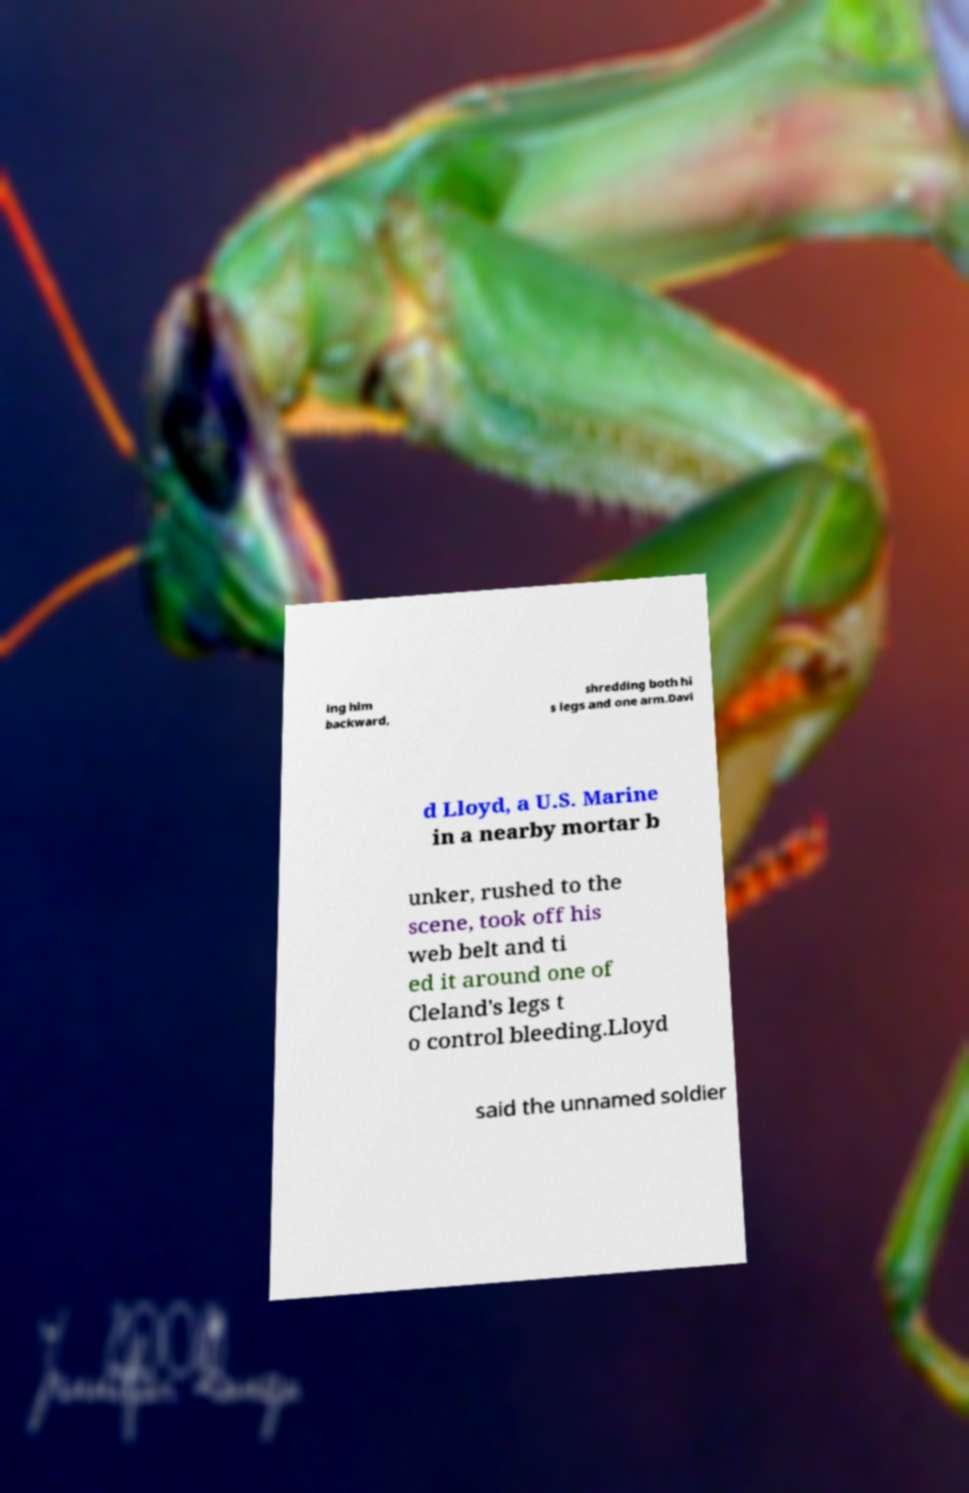Can you accurately transcribe the text from the provided image for me? ing him backward, shredding both hi s legs and one arm.Davi d Lloyd, a U.S. Marine in a nearby mortar b unker, rushed to the scene, took off his web belt and ti ed it around one of Cleland's legs t o control bleeding.Lloyd said the unnamed soldier 